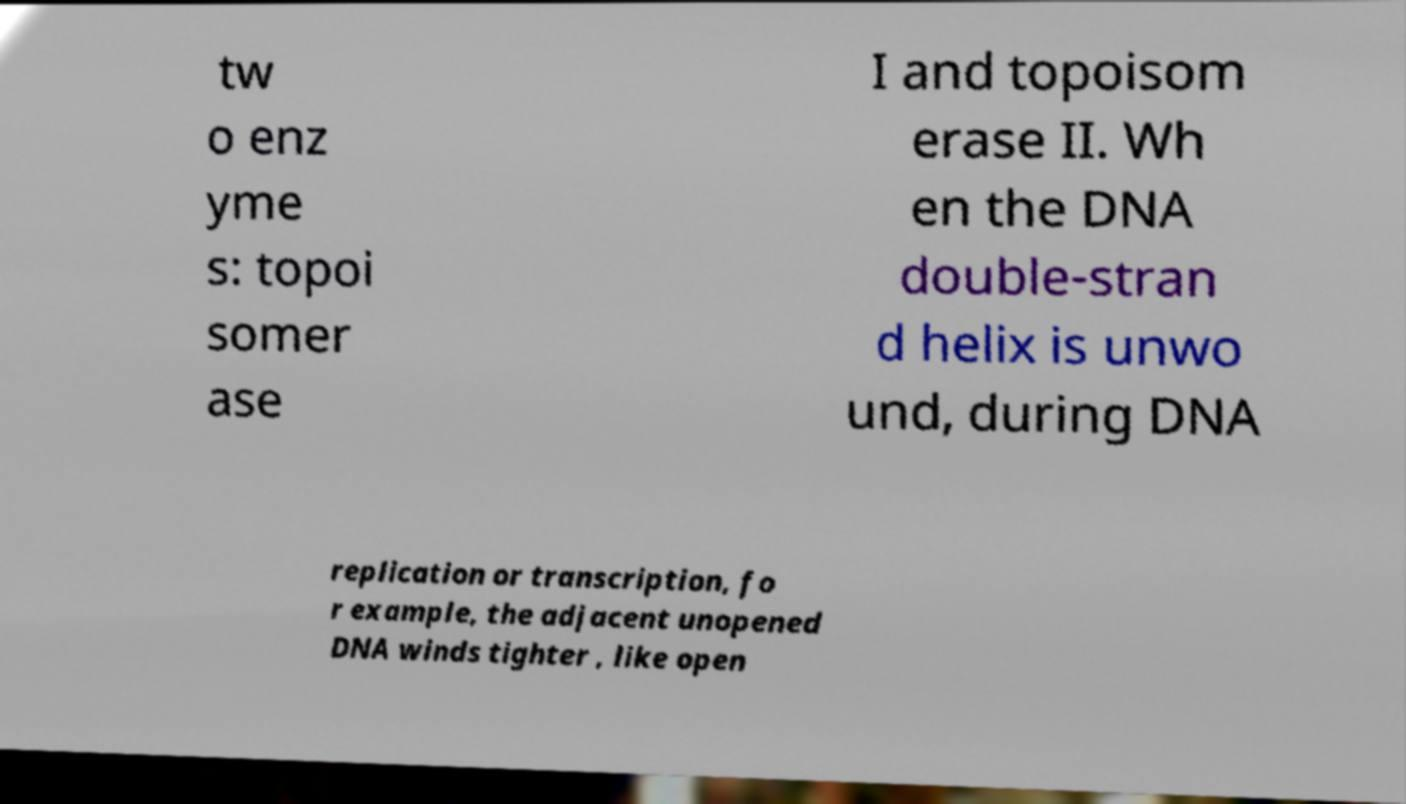Please read and relay the text visible in this image. What does it say? tw o enz yme s: topoi somer ase I and topoisom erase II. Wh en the DNA double-stran d helix is unwo und, during DNA replication or transcription, fo r example, the adjacent unopened DNA winds tighter , like open 